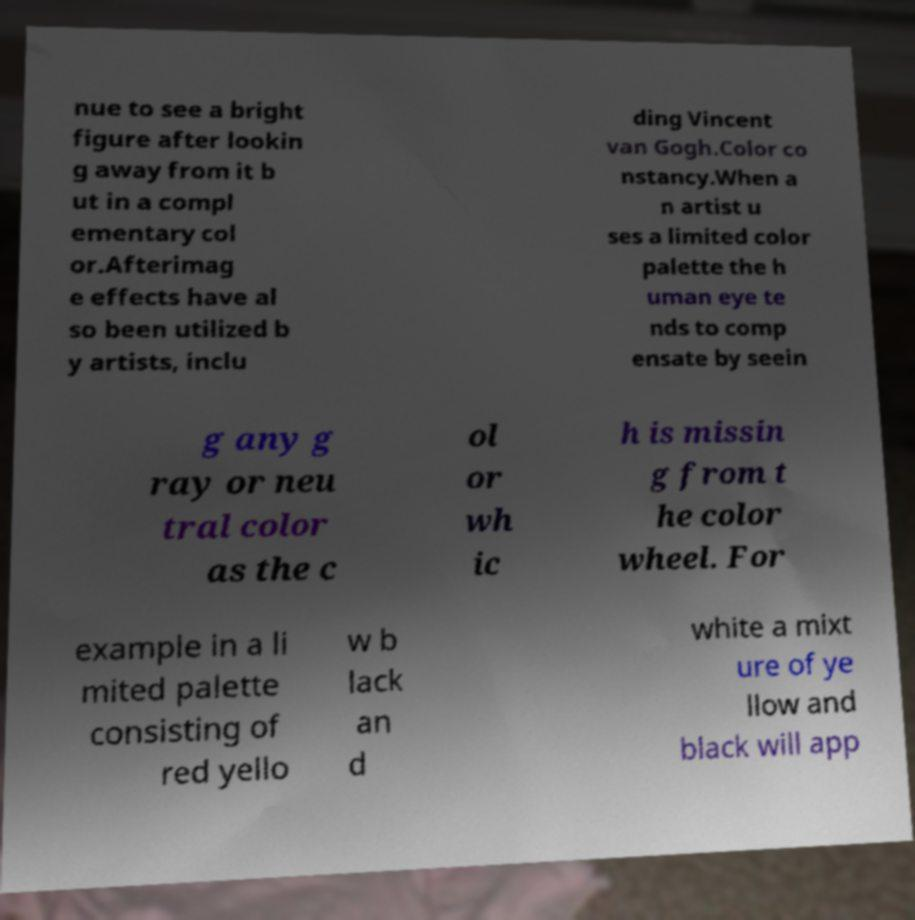Can you accurately transcribe the text from the provided image for me? nue to see a bright figure after lookin g away from it b ut in a compl ementary col or.Afterimag e effects have al so been utilized b y artists, inclu ding Vincent van Gogh.Color co nstancy.When a n artist u ses a limited color palette the h uman eye te nds to comp ensate by seein g any g ray or neu tral color as the c ol or wh ic h is missin g from t he color wheel. For example in a li mited palette consisting of red yello w b lack an d white a mixt ure of ye llow and black will app 